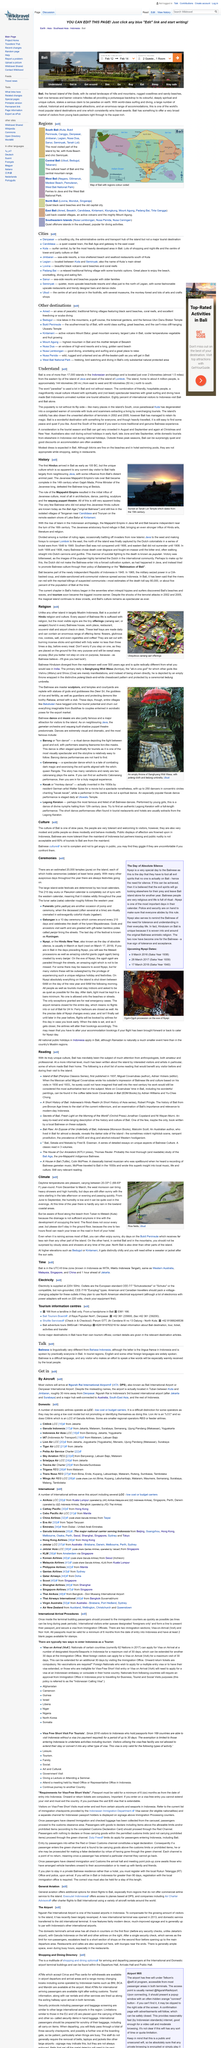Indicate a few pertinent items in this graphic. The daytime temperatures in the area range between 20°C and 33°C all year round. The location of the rice fields depicted in the photograph is Ubud. The occasional flooding along the beach from Tuban to Melasti is due to insufficient drainage, caused by the development of the occupying land. 